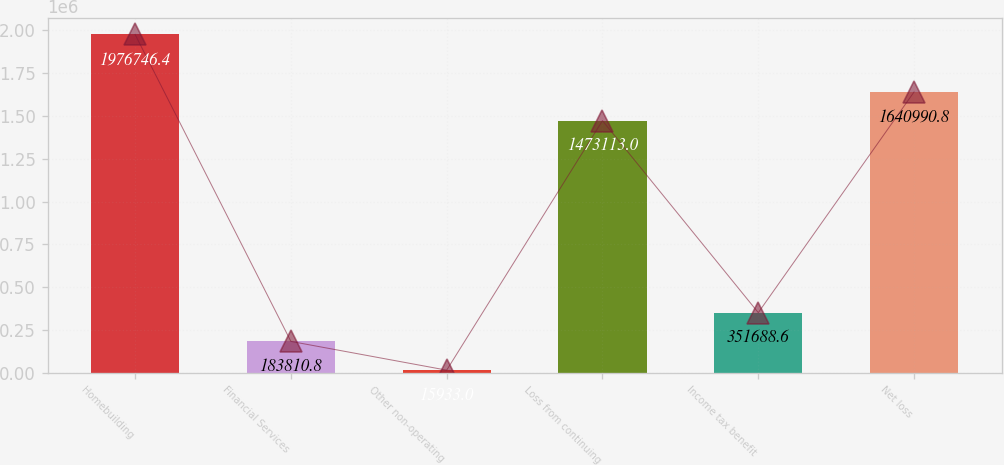Convert chart. <chart><loc_0><loc_0><loc_500><loc_500><bar_chart><fcel>Homebuilding<fcel>Financial Services<fcel>Other non-operating<fcel>Loss from continuing<fcel>Income tax benefit<fcel>Net loss<nl><fcel>1.97675e+06<fcel>183811<fcel>15933<fcel>1.47311e+06<fcel>351689<fcel>1.64099e+06<nl></chart> 